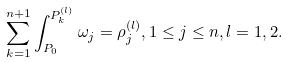<formula> <loc_0><loc_0><loc_500><loc_500>\sum _ { k = 1 } ^ { n + 1 } \int _ { P _ { 0 } } ^ { P _ { k } ^ { ( l ) } } \omega _ { j } = \rho ^ { ( l ) } _ { j } , 1 \leq j \leq n , l = 1 , 2 .</formula> 